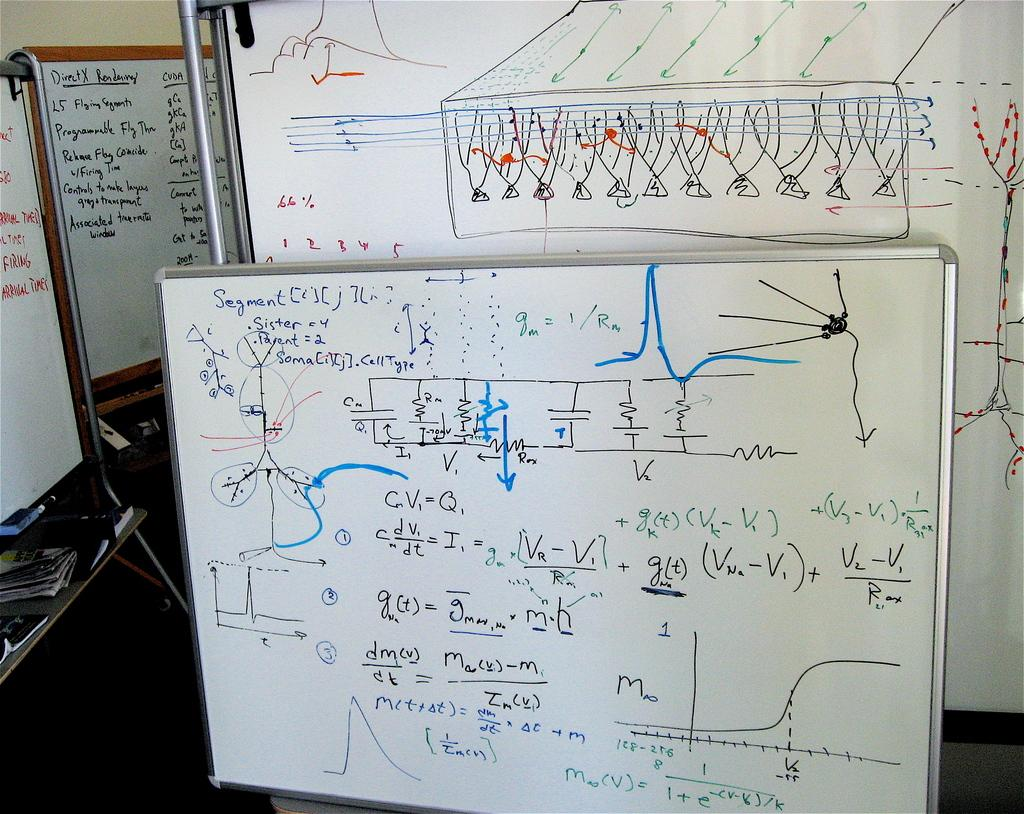What type of boards are present in the image? There are white color boards in the image. What is on the boards? There is writing on the boards. What colors are used for the writing? The writing is in black and blue colors. What color is the background wall? The background wall is in cream color. What type of canvas is being used to create the roll in the image? There is no roll or canvas present in the image; it features white color boards with writing on them. 